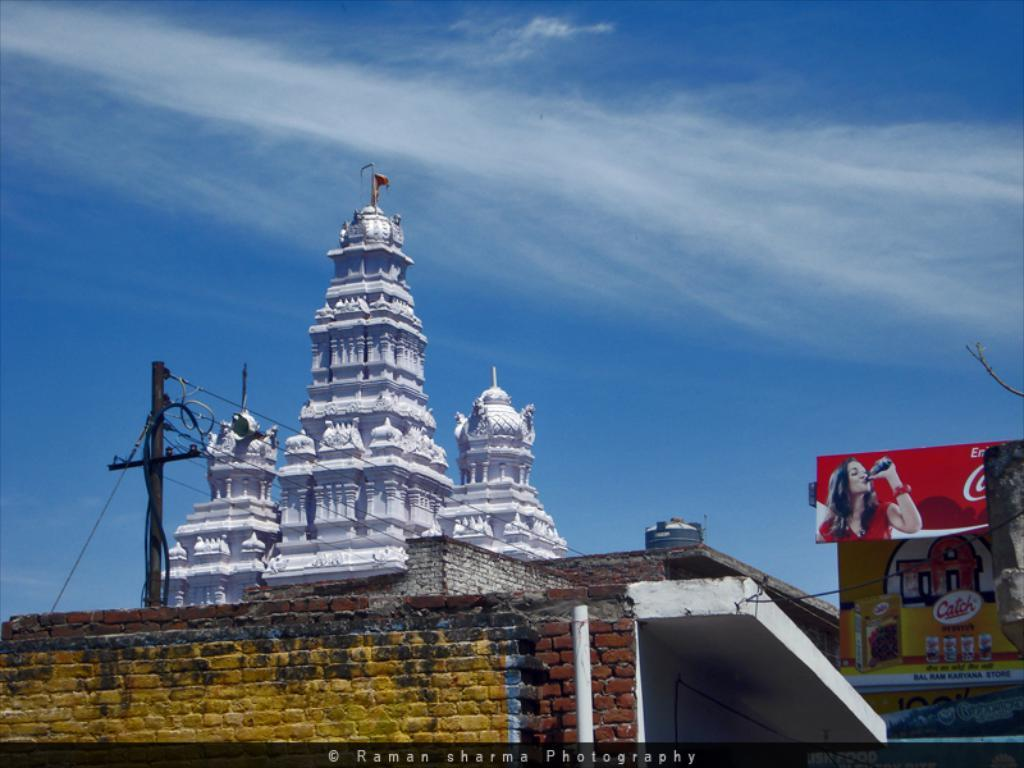What type of structure is present in the image? There is a building in the image. Can you describe the color of the building? The building is white. What other objects can be seen in the image? There is a brick wall, current poles, a water tank, wires, and banners in the image. What is the color of the sky in the image? The sky is blue. What type of thought can be seen in the image? There are no thoughts visible in the image; it contains physical objects such as a building, brick wall, current poles, water tank, wires, and banners. Is there a bear present in the image? No, there is no bear present in the image. 